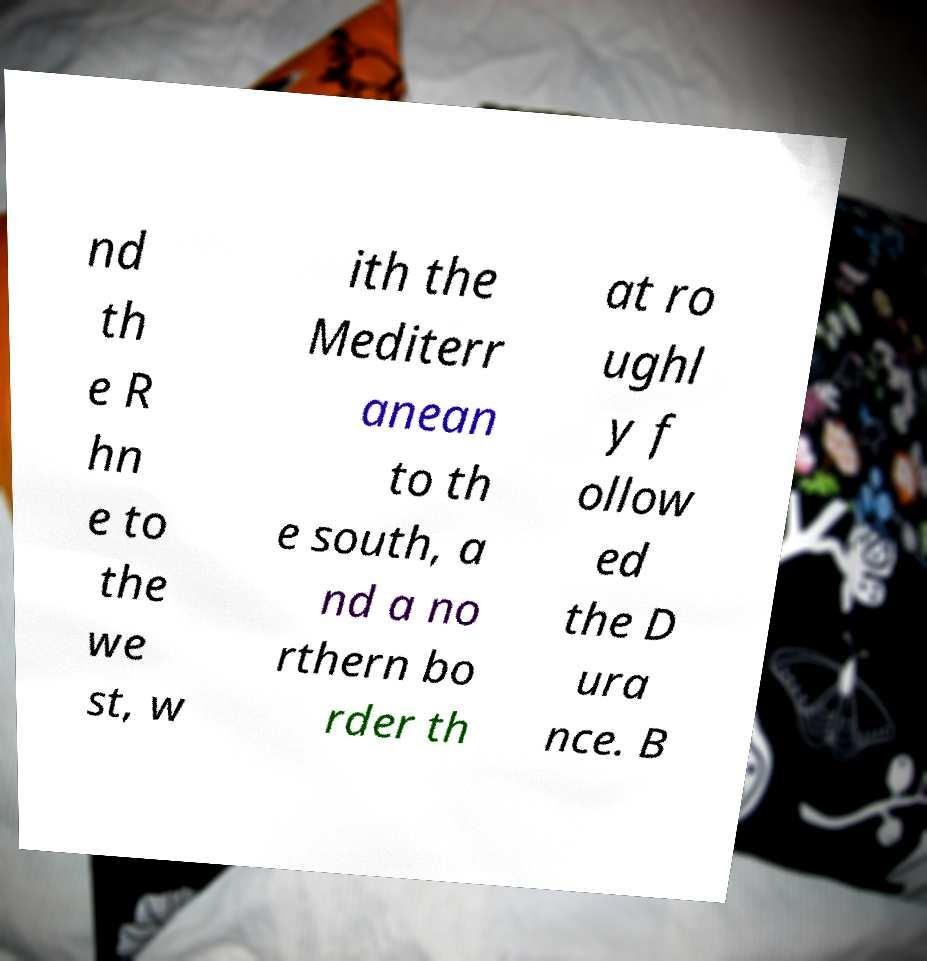Could you extract and type out the text from this image? nd th e R hn e to the we st, w ith the Mediterr anean to th e south, a nd a no rthern bo rder th at ro ughl y f ollow ed the D ura nce. B 